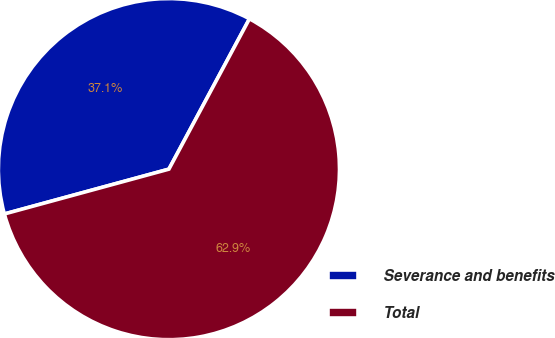Convert chart. <chart><loc_0><loc_0><loc_500><loc_500><pie_chart><fcel>Severance and benefits<fcel>Total<nl><fcel>37.06%<fcel>62.94%<nl></chart> 